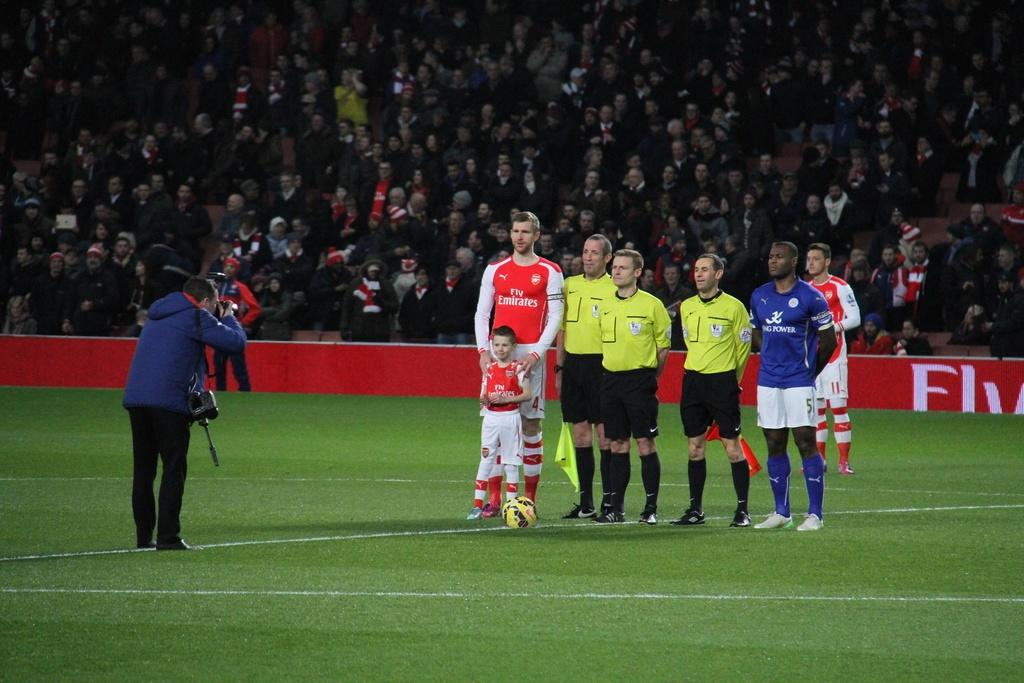<image>
Write a terse but informative summary of the picture. A photographer is taking a picture of soccer players and a child wearing a Fly Emirates shirt on a soccor field. 